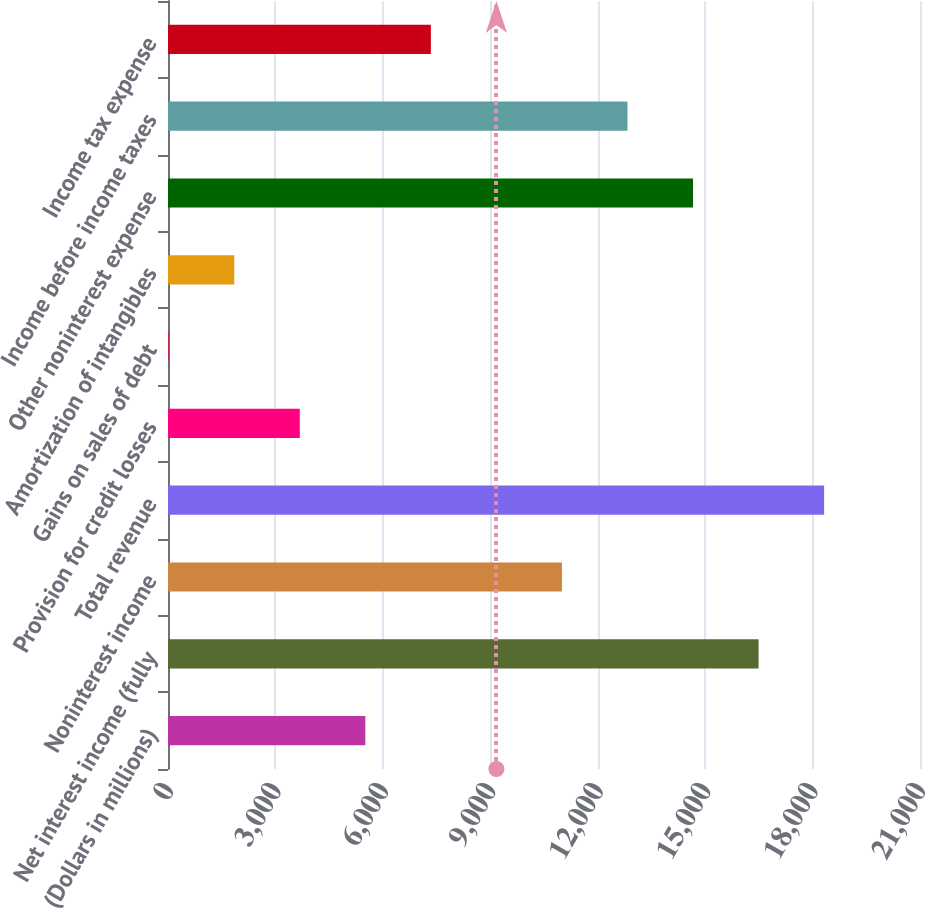<chart> <loc_0><loc_0><loc_500><loc_500><bar_chart><fcel>(Dollars in millions)<fcel>Net interest income (fully<fcel>Noninterest income<fcel>Total revenue<fcel>Provision for credit losses<fcel>Gains on sales of debt<fcel>Amortization of intangibles<fcel>Other noninterest expense<fcel>Income before income taxes<fcel>Income tax expense<nl><fcel>5510.6<fcel>16491.8<fcel>11001.2<fcel>18322<fcel>3680.4<fcel>20<fcel>1850.2<fcel>14661.6<fcel>12831.4<fcel>7340.8<nl></chart> 